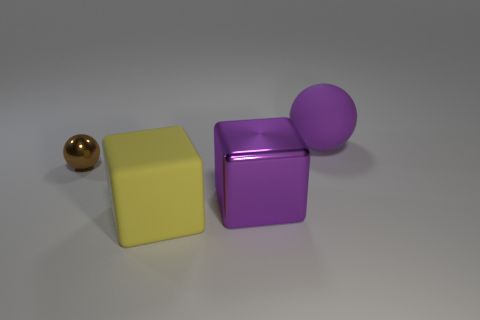What is the shape of the purple metallic object that is the same size as the matte block?
Your answer should be very brief. Cube. What number of tiny metallic balls are the same color as the large metallic cube?
Your response must be concise. 0. Is the material of the large purple thing in front of the small brown metallic ball the same as the tiny sphere?
Provide a succinct answer. Yes. The small brown shiny thing is what shape?
Your response must be concise. Sphere. How many brown things are either metallic balls or shiny cubes?
Offer a very short reply. 1. How many other objects are there of the same material as the brown ball?
Offer a very short reply. 1. Does the shiny object that is to the right of the small object have the same shape as the brown thing?
Offer a terse response. No. Is there a large object?
Your answer should be very brief. Yes. Is there anything else that is the same shape as the large purple rubber object?
Offer a very short reply. Yes. Is the number of metal objects that are behind the big purple metallic cube greater than the number of tiny brown cubes?
Give a very brief answer. Yes. 